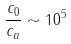Convert formula to latex. <formula><loc_0><loc_0><loc_500><loc_500>\frac { c _ { 0 } } { c _ { a } } \sim 1 0 ^ { 5 }</formula> 